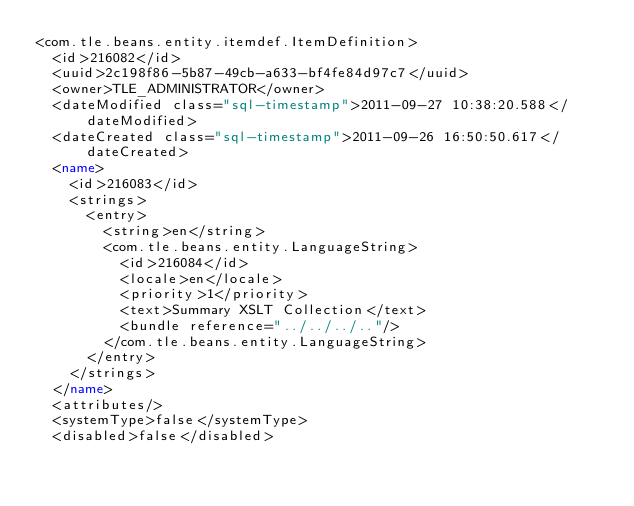Convert code to text. <code><loc_0><loc_0><loc_500><loc_500><_XML_><com.tle.beans.entity.itemdef.ItemDefinition>
  <id>216082</id>
  <uuid>2c198f86-5b87-49cb-a633-bf4fe84d97c7</uuid>
  <owner>TLE_ADMINISTRATOR</owner>
  <dateModified class="sql-timestamp">2011-09-27 10:38:20.588</dateModified>
  <dateCreated class="sql-timestamp">2011-09-26 16:50:50.617</dateCreated>
  <name>
    <id>216083</id>
    <strings>
      <entry>
        <string>en</string>
        <com.tle.beans.entity.LanguageString>
          <id>216084</id>
          <locale>en</locale>
          <priority>1</priority>
          <text>Summary XSLT Collection</text>
          <bundle reference="../../../.."/>
        </com.tle.beans.entity.LanguageString>
      </entry>
    </strings>
  </name>
  <attributes/>
  <systemType>false</systemType>
  <disabled>false</disabled></code> 